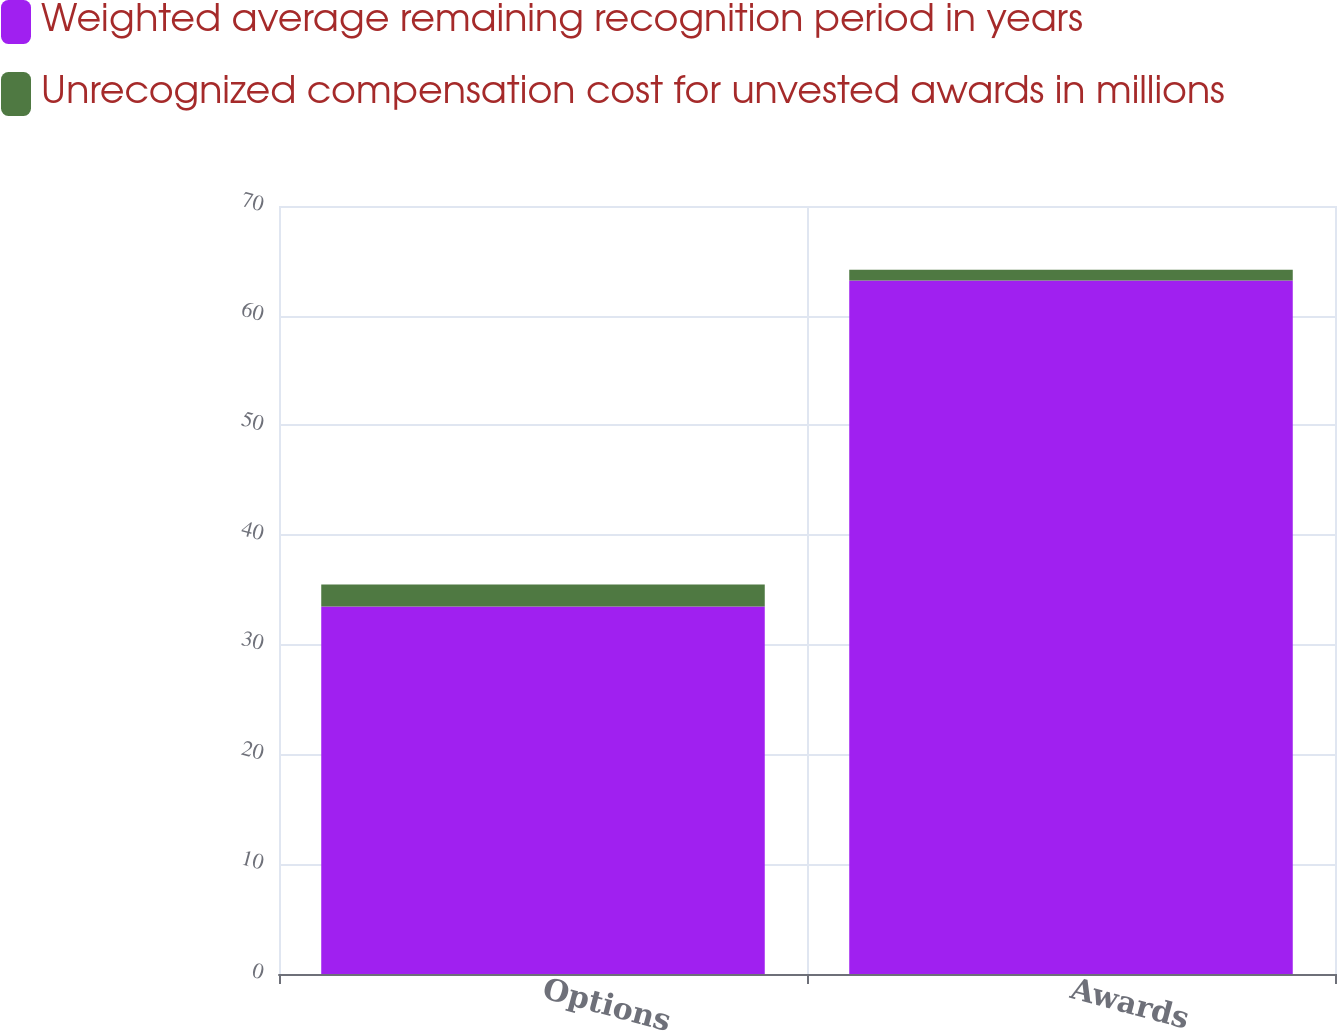<chart> <loc_0><loc_0><loc_500><loc_500><stacked_bar_chart><ecel><fcel>Options<fcel>Awards<nl><fcel>Weighted average remaining recognition period in years<fcel>33.5<fcel>63.2<nl><fcel>Unrecognized compensation cost for unvested awards in millions<fcel>2<fcel>1<nl></chart> 